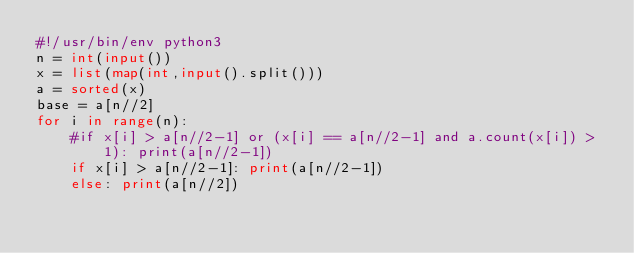Convert code to text. <code><loc_0><loc_0><loc_500><loc_500><_Python_>#!/usr/bin/env python3
n = int(input())
x = list(map(int,input().split()))
a = sorted(x)
base = a[n//2]
for i in range(n):
    #if x[i] > a[n//2-1] or (x[i] == a[n//2-1] and a.count(x[i]) > 1): print(a[n//2-1])
    if x[i] > a[n//2-1]: print(a[n//2-1])
    else: print(a[n//2])</code> 